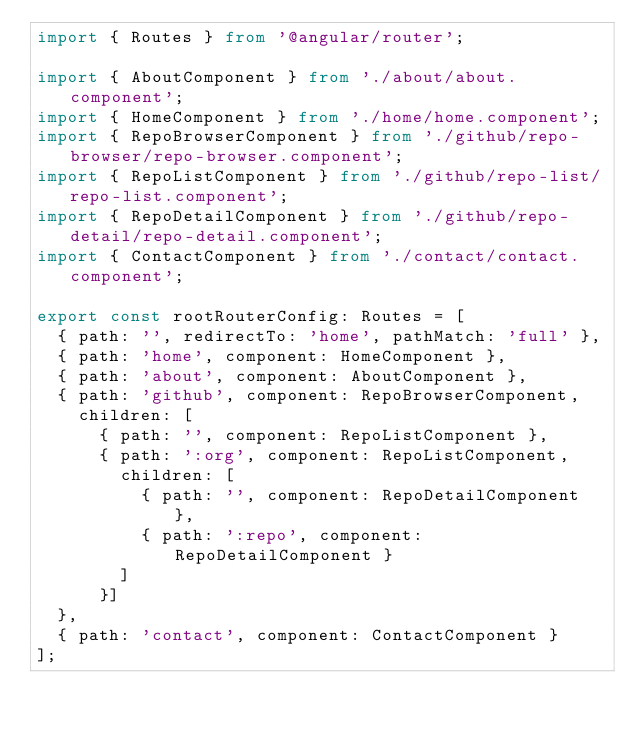<code> <loc_0><loc_0><loc_500><loc_500><_TypeScript_>import { Routes } from '@angular/router';

import { AboutComponent } from './about/about.component';
import { HomeComponent } from './home/home.component';
import { RepoBrowserComponent } from './github/repo-browser/repo-browser.component';
import { RepoListComponent } from './github/repo-list/repo-list.component';
import { RepoDetailComponent } from './github/repo-detail/repo-detail.component';
import { ContactComponent } from './contact/contact.component';

export const rootRouterConfig: Routes = [
  { path: '', redirectTo: 'home', pathMatch: 'full' },
  { path: 'home', component: HomeComponent },
  { path: 'about', component: AboutComponent },
  { path: 'github', component: RepoBrowserComponent,
    children: [
      { path: '', component: RepoListComponent },
      { path: ':org', component: RepoListComponent,
        children: [
          { path: '', component: RepoDetailComponent },
          { path: ':repo', component: RepoDetailComponent }
        ]
      }]
  },
  { path: 'contact', component: ContactComponent }
];

</code> 